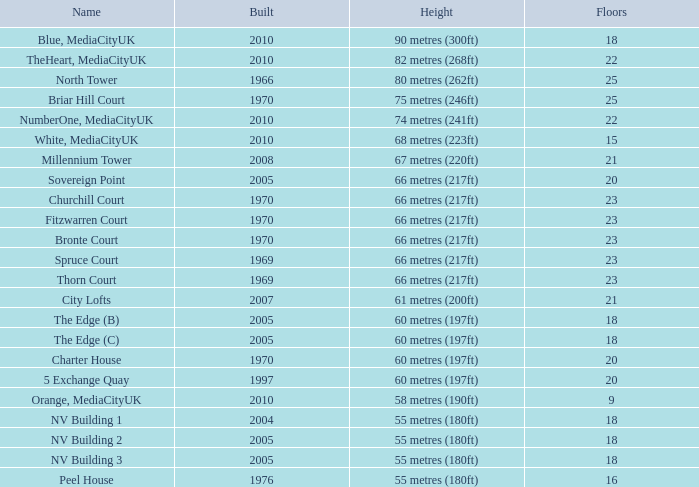What is the elevation, when position is under 20, when levels is over 9, when constructed is 2005, and when title is the edge (c)? 60 metres (197ft). 